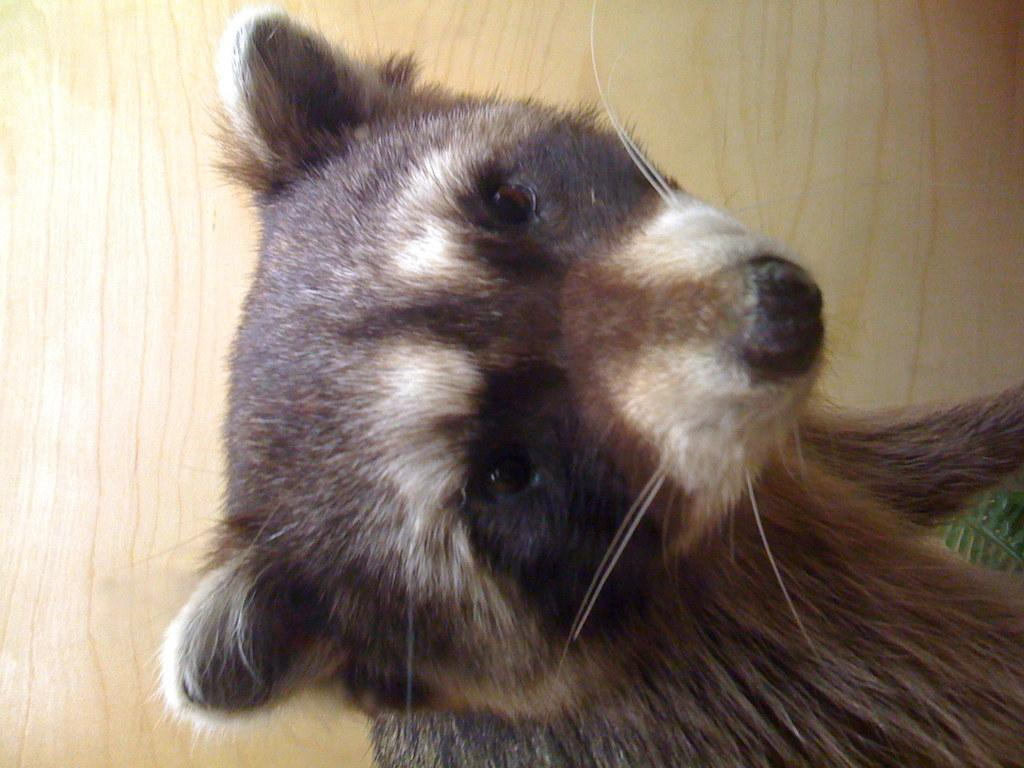In which direction is the image oriented? The image is oriented towards the leftward direction. What can be found at the bottom of the image? There is an animal at the bottom of the image. What is visible in the background of the image? There is a wood in the background of the image. What is the weight of the car in the image? There is no car present in the image, so it is not possible to determine its weight. 